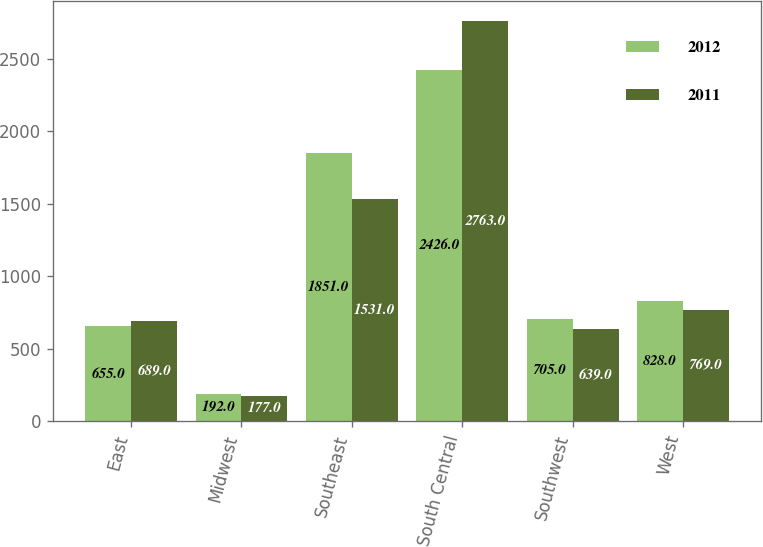Convert chart. <chart><loc_0><loc_0><loc_500><loc_500><stacked_bar_chart><ecel><fcel>East<fcel>Midwest<fcel>Southeast<fcel>South Central<fcel>Southwest<fcel>West<nl><fcel>2012<fcel>655<fcel>192<fcel>1851<fcel>2426<fcel>705<fcel>828<nl><fcel>2011<fcel>689<fcel>177<fcel>1531<fcel>2763<fcel>639<fcel>769<nl></chart> 